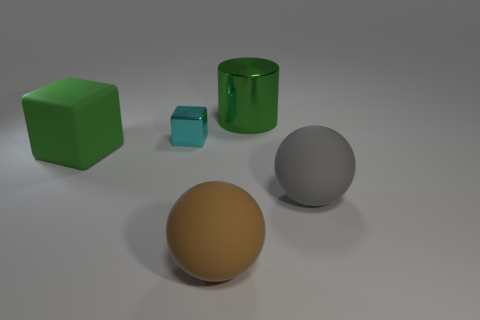Is there anything else that is the same size as the cyan block?
Make the answer very short. No. Is there anything else that has the same shape as the big metal object?
Offer a terse response. No. There is a big brown thing that is the same shape as the gray rubber object; what material is it?
Offer a very short reply. Rubber. Is there anything else that is made of the same material as the big green cylinder?
Keep it short and to the point. Yes. What color is the big rubber cube?
Your answer should be very brief. Green. Is the tiny object the same color as the big cube?
Keep it short and to the point. No. What number of matte spheres are in front of the rubber object on the left side of the brown matte ball?
Keep it short and to the point. 2. What is the size of the rubber object that is both behind the big brown sphere and left of the cylinder?
Offer a very short reply. Large. What is the material of the sphere left of the gray matte thing?
Offer a very short reply. Rubber. Are there any big matte things of the same shape as the large green metal object?
Your answer should be compact. No. 